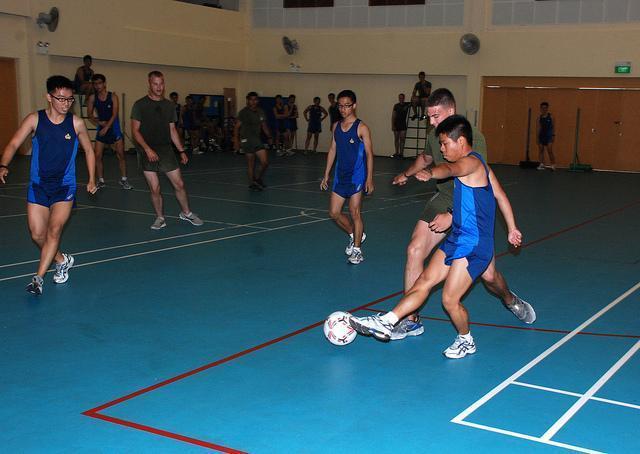How many men are playing with the ball?
Give a very brief answer. 2. How many people are there?
Give a very brief answer. 8. How many giraffes are looking away from the camera?
Give a very brief answer. 0. 